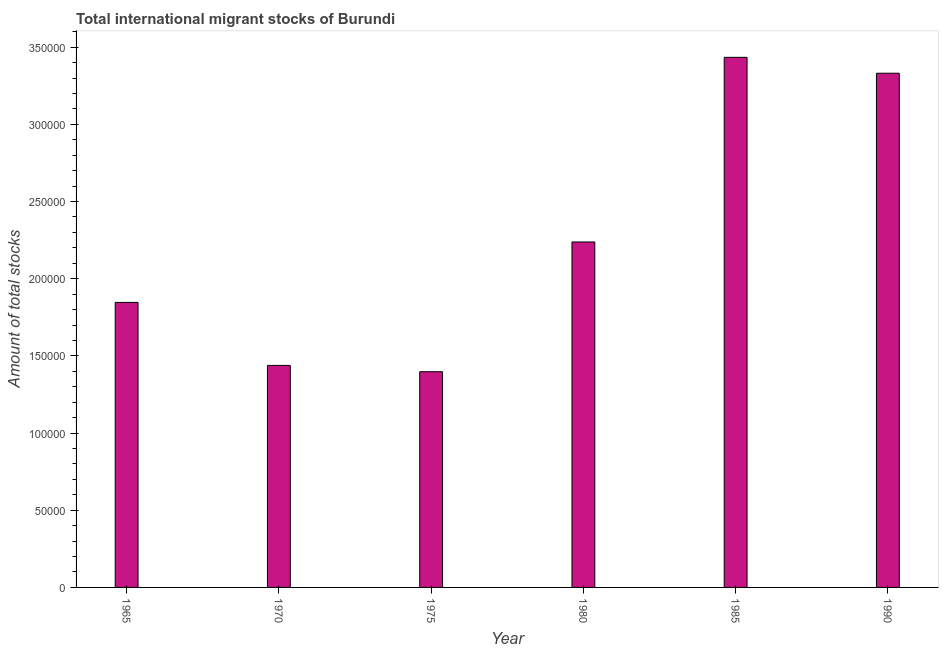What is the title of the graph?
Offer a very short reply. Total international migrant stocks of Burundi. What is the label or title of the Y-axis?
Provide a succinct answer. Amount of total stocks. What is the total number of international migrant stock in 1990?
Make the answer very short. 3.33e+05. Across all years, what is the maximum total number of international migrant stock?
Ensure brevity in your answer.  3.43e+05. Across all years, what is the minimum total number of international migrant stock?
Your answer should be very brief. 1.40e+05. In which year was the total number of international migrant stock minimum?
Your answer should be very brief. 1975. What is the sum of the total number of international migrant stock?
Your response must be concise. 1.37e+06. What is the difference between the total number of international migrant stock in 1965 and 1980?
Ensure brevity in your answer.  -3.92e+04. What is the average total number of international migrant stock per year?
Provide a succinct answer. 2.28e+05. What is the median total number of international migrant stock?
Offer a very short reply. 2.04e+05. In how many years, is the total number of international migrant stock greater than 130000 ?
Ensure brevity in your answer.  6. Do a majority of the years between 1975 and 1985 (inclusive) have total number of international migrant stock greater than 150000 ?
Make the answer very short. Yes. What is the ratio of the total number of international migrant stock in 1980 to that in 1990?
Your answer should be compact. 0.67. Is the total number of international migrant stock in 1970 less than that in 1975?
Make the answer very short. No. What is the difference between the highest and the second highest total number of international migrant stock?
Your response must be concise. 1.03e+04. What is the difference between the highest and the lowest total number of international migrant stock?
Your answer should be compact. 2.04e+05. How many years are there in the graph?
Ensure brevity in your answer.  6. Are the values on the major ticks of Y-axis written in scientific E-notation?
Your answer should be very brief. No. What is the Amount of total stocks of 1965?
Provide a succinct answer. 1.85e+05. What is the Amount of total stocks in 1970?
Provide a succinct answer. 1.44e+05. What is the Amount of total stocks in 1975?
Provide a succinct answer. 1.40e+05. What is the Amount of total stocks of 1980?
Your response must be concise. 2.24e+05. What is the Amount of total stocks in 1985?
Keep it short and to the point. 3.43e+05. What is the Amount of total stocks of 1990?
Your answer should be compact. 3.33e+05. What is the difference between the Amount of total stocks in 1965 and 1970?
Your answer should be compact. 4.08e+04. What is the difference between the Amount of total stocks in 1965 and 1975?
Offer a terse response. 4.49e+04. What is the difference between the Amount of total stocks in 1965 and 1980?
Provide a succinct answer. -3.92e+04. What is the difference between the Amount of total stocks in 1965 and 1985?
Your answer should be compact. -1.59e+05. What is the difference between the Amount of total stocks in 1965 and 1990?
Ensure brevity in your answer.  -1.48e+05. What is the difference between the Amount of total stocks in 1970 and 1975?
Give a very brief answer. 4079. What is the difference between the Amount of total stocks in 1970 and 1980?
Your answer should be very brief. -8.00e+04. What is the difference between the Amount of total stocks in 1970 and 1985?
Provide a succinct answer. -2.00e+05. What is the difference between the Amount of total stocks in 1970 and 1990?
Your response must be concise. -1.89e+05. What is the difference between the Amount of total stocks in 1975 and 1980?
Make the answer very short. -8.40e+04. What is the difference between the Amount of total stocks in 1975 and 1985?
Make the answer very short. -2.04e+05. What is the difference between the Amount of total stocks in 1975 and 1990?
Ensure brevity in your answer.  -1.93e+05. What is the difference between the Amount of total stocks in 1980 and 1985?
Your response must be concise. -1.20e+05. What is the difference between the Amount of total stocks in 1980 and 1990?
Ensure brevity in your answer.  -1.09e+05. What is the difference between the Amount of total stocks in 1985 and 1990?
Make the answer very short. 1.03e+04. What is the ratio of the Amount of total stocks in 1965 to that in 1970?
Your answer should be very brief. 1.28. What is the ratio of the Amount of total stocks in 1965 to that in 1975?
Keep it short and to the point. 1.32. What is the ratio of the Amount of total stocks in 1965 to that in 1980?
Ensure brevity in your answer.  0.82. What is the ratio of the Amount of total stocks in 1965 to that in 1985?
Keep it short and to the point. 0.54. What is the ratio of the Amount of total stocks in 1965 to that in 1990?
Make the answer very short. 0.55. What is the ratio of the Amount of total stocks in 1970 to that in 1980?
Give a very brief answer. 0.64. What is the ratio of the Amount of total stocks in 1970 to that in 1985?
Provide a succinct answer. 0.42. What is the ratio of the Amount of total stocks in 1970 to that in 1990?
Your answer should be compact. 0.43. What is the ratio of the Amount of total stocks in 1975 to that in 1980?
Make the answer very short. 0.62. What is the ratio of the Amount of total stocks in 1975 to that in 1985?
Offer a terse response. 0.41. What is the ratio of the Amount of total stocks in 1975 to that in 1990?
Your answer should be very brief. 0.42. What is the ratio of the Amount of total stocks in 1980 to that in 1985?
Offer a terse response. 0.65. What is the ratio of the Amount of total stocks in 1980 to that in 1990?
Ensure brevity in your answer.  0.67. What is the ratio of the Amount of total stocks in 1985 to that in 1990?
Provide a short and direct response. 1.03. 